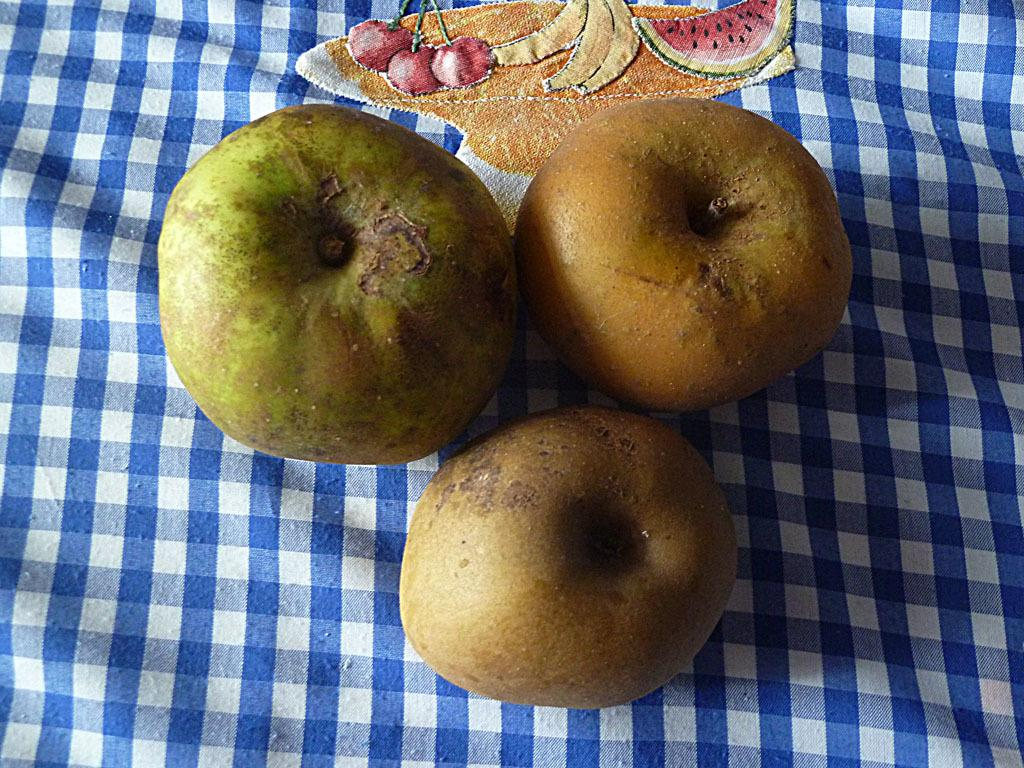What is placed on the cloth in the image? There are fruits on a cloth in the image. What design can be seen on the cloth in the image? There is an embroidery of fruits on the cloth in the image. What does your mom say about the embroidery of fangs on the cloth in the image? There is no mention of a mom or fangs in the image; it features fruits on a cloth with an embroidery of fruits. 